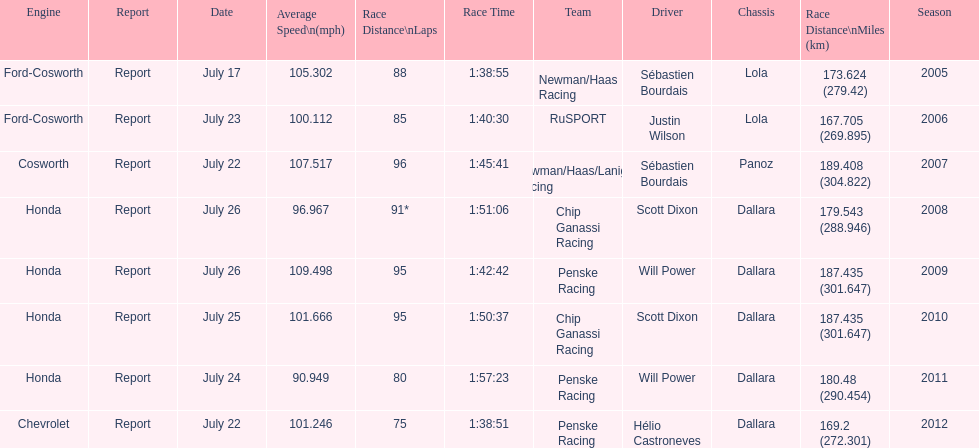What is the least amount of laps completed? 75. Write the full table. {'header': ['Engine', 'Report', 'Date', 'Average Speed\\n(mph)', 'Race Distance\\nLaps', 'Race Time', 'Team', 'Driver', 'Chassis', 'Race Distance\\nMiles (km)', 'Season'], 'rows': [['Ford-Cosworth', 'Report', 'July 17', '105.302', '88', '1:38:55', 'Newman/Haas Racing', 'Sébastien Bourdais', 'Lola', '173.624 (279.42)', '2005'], ['Ford-Cosworth', 'Report', 'July 23', '100.112', '85', '1:40:30', 'RuSPORT', 'Justin Wilson', 'Lola', '167.705 (269.895)', '2006'], ['Cosworth', 'Report', 'July 22', '107.517', '96', '1:45:41', 'Newman/Haas/Lanigan Racing', 'Sébastien Bourdais', 'Panoz', '189.408 (304.822)', '2007'], ['Honda', 'Report', 'July 26', '96.967', '91*', '1:51:06', 'Chip Ganassi Racing', 'Scott Dixon', 'Dallara', '179.543 (288.946)', '2008'], ['Honda', 'Report', 'July 26', '109.498', '95', '1:42:42', 'Penske Racing', 'Will Power', 'Dallara', '187.435 (301.647)', '2009'], ['Honda', 'Report', 'July 25', '101.666', '95', '1:50:37', 'Chip Ganassi Racing', 'Scott Dixon', 'Dallara', '187.435 (301.647)', '2010'], ['Honda', 'Report', 'July 24', '90.949', '80', '1:57:23', 'Penske Racing', 'Will Power', 'Dallara', '180.48 (290.454)', '2011'], ['Chevrolet', 'Report', 'July 22', '101.246', '75', '1:38:51', 'Penske Racing', 'Hélio Castroneves', 'Dallara', '169.2 (272.301)', '2012']]} 